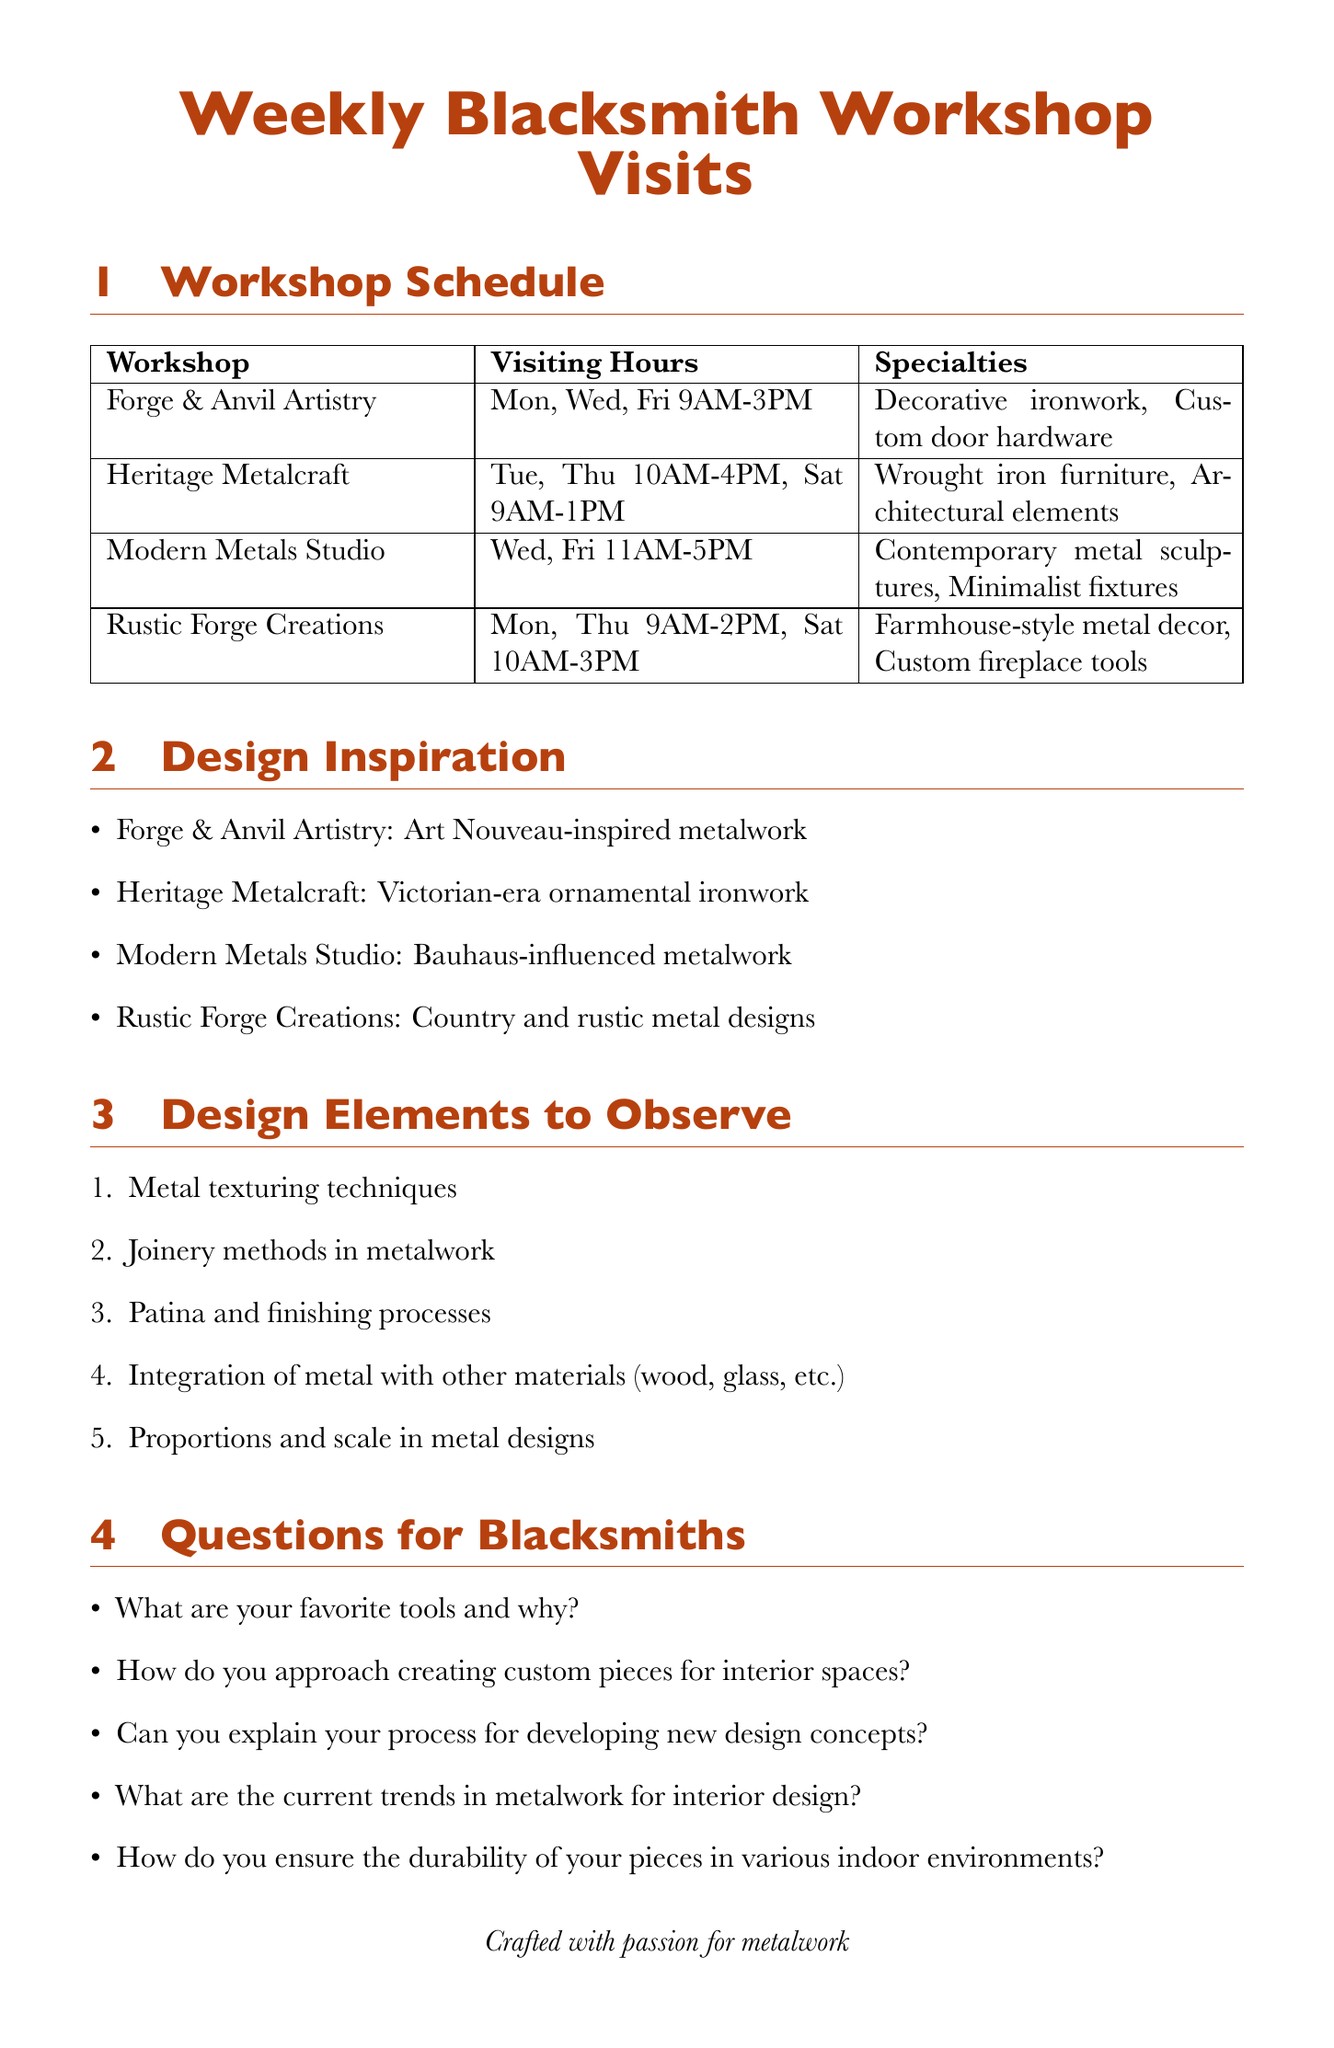What is the address of Heritage Metalcraft? The address of Heritage Metalcraft is explicitly stated in the document as 456 Steel Street, Forgeton.
Answer: 456 Steel Street, Forgeton What are the visiting hours for Modern Metals Studio? The visiting hours for Modern Metals Studio are outlined in the document as Wednesday and Friday from 11AM to 5PM.
Answer: Wednesday, Friday 11AM-5PM Which workshop specializes in farmhouse-style metal decor? The document specifies that Rustic Forge Creations specializes in farmhouse-style metal decor.
Answer: Rustic Forge Creations What design inspiration does Forge & Anvil Artistry use? The document lists Art Nouveau-inspired metalwork as the design inspiration for Forge & Anvil Artistry.
Answer: Art Nouveau-inspired metalwork How many design elements to observe are listed in the document? The document includes a total of five design elements to observe, making them countable.
Answer: 5 What is one potential collaboration idea mentioned? The document presents a list of potential collaboration ideas, and one is unique metal-framed mirrors.
Answer: Unique metal-framed mirrors Which days can you visit Forge & Anvil Artistry? The document specifies the visiting days for Forge & Anvil Artistry as Monday, Wednesday, and Friday.
Answer: Monday, Wednesday, Friday What is the first item under workshop etiquette? The first item under workshop etiquette states to always call ahead to confirm a visit.
Answer: Always call ahead to confirm visit What type of metalwork is highlighted as a specialty of Heritage Metalcraft? The document details wrought iron furniture as one of the specialties of Heritage Metalcraft.
Answer: Wrought iron furniture 